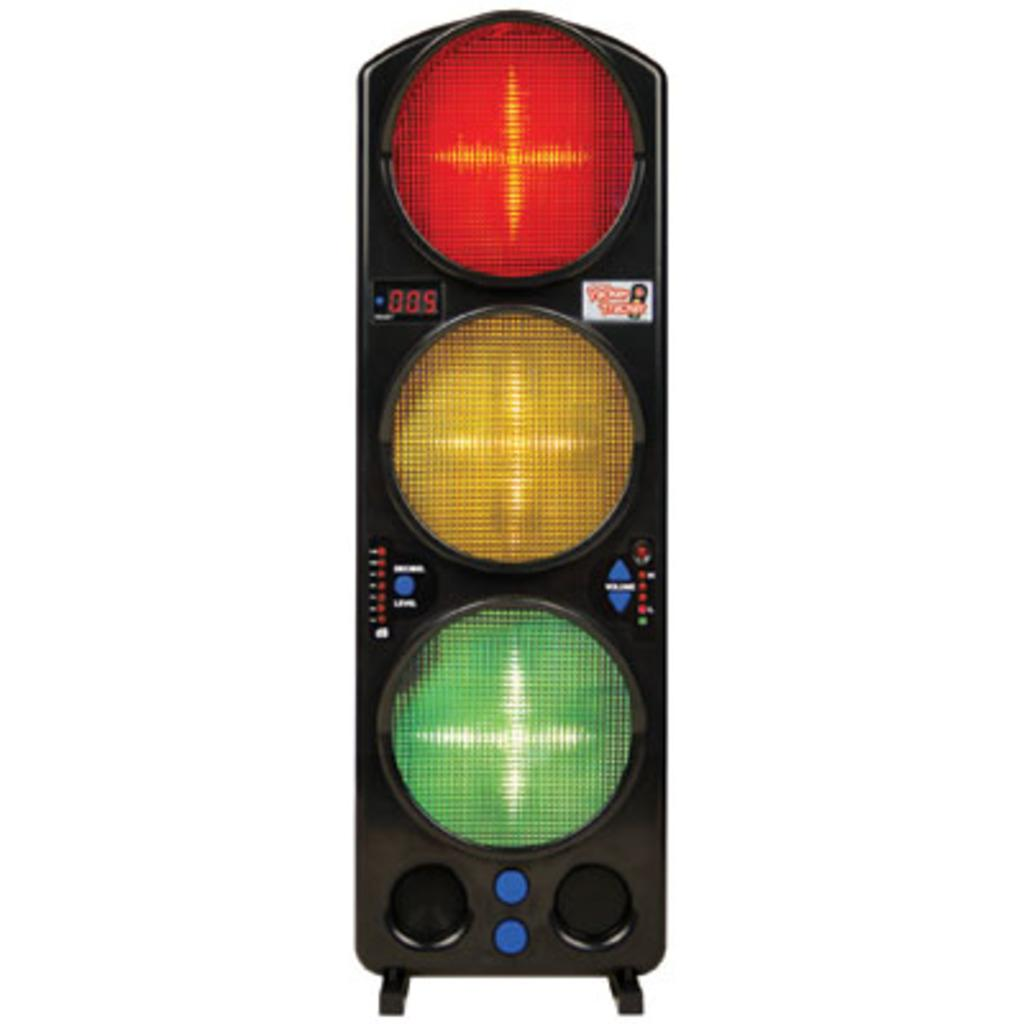What is the main subject of the picture? The main subject of the picture is a traffic signal. What colors are present on the traffic signal? The traffic signal has red, yellow, and green lights. What is the color of the background in the image? The background of the image is white. Can you see any snails crawling on the traffic signal in the image? There are no snails present in the image, and therefore no snails can be seen crawling on the traffic signal. 